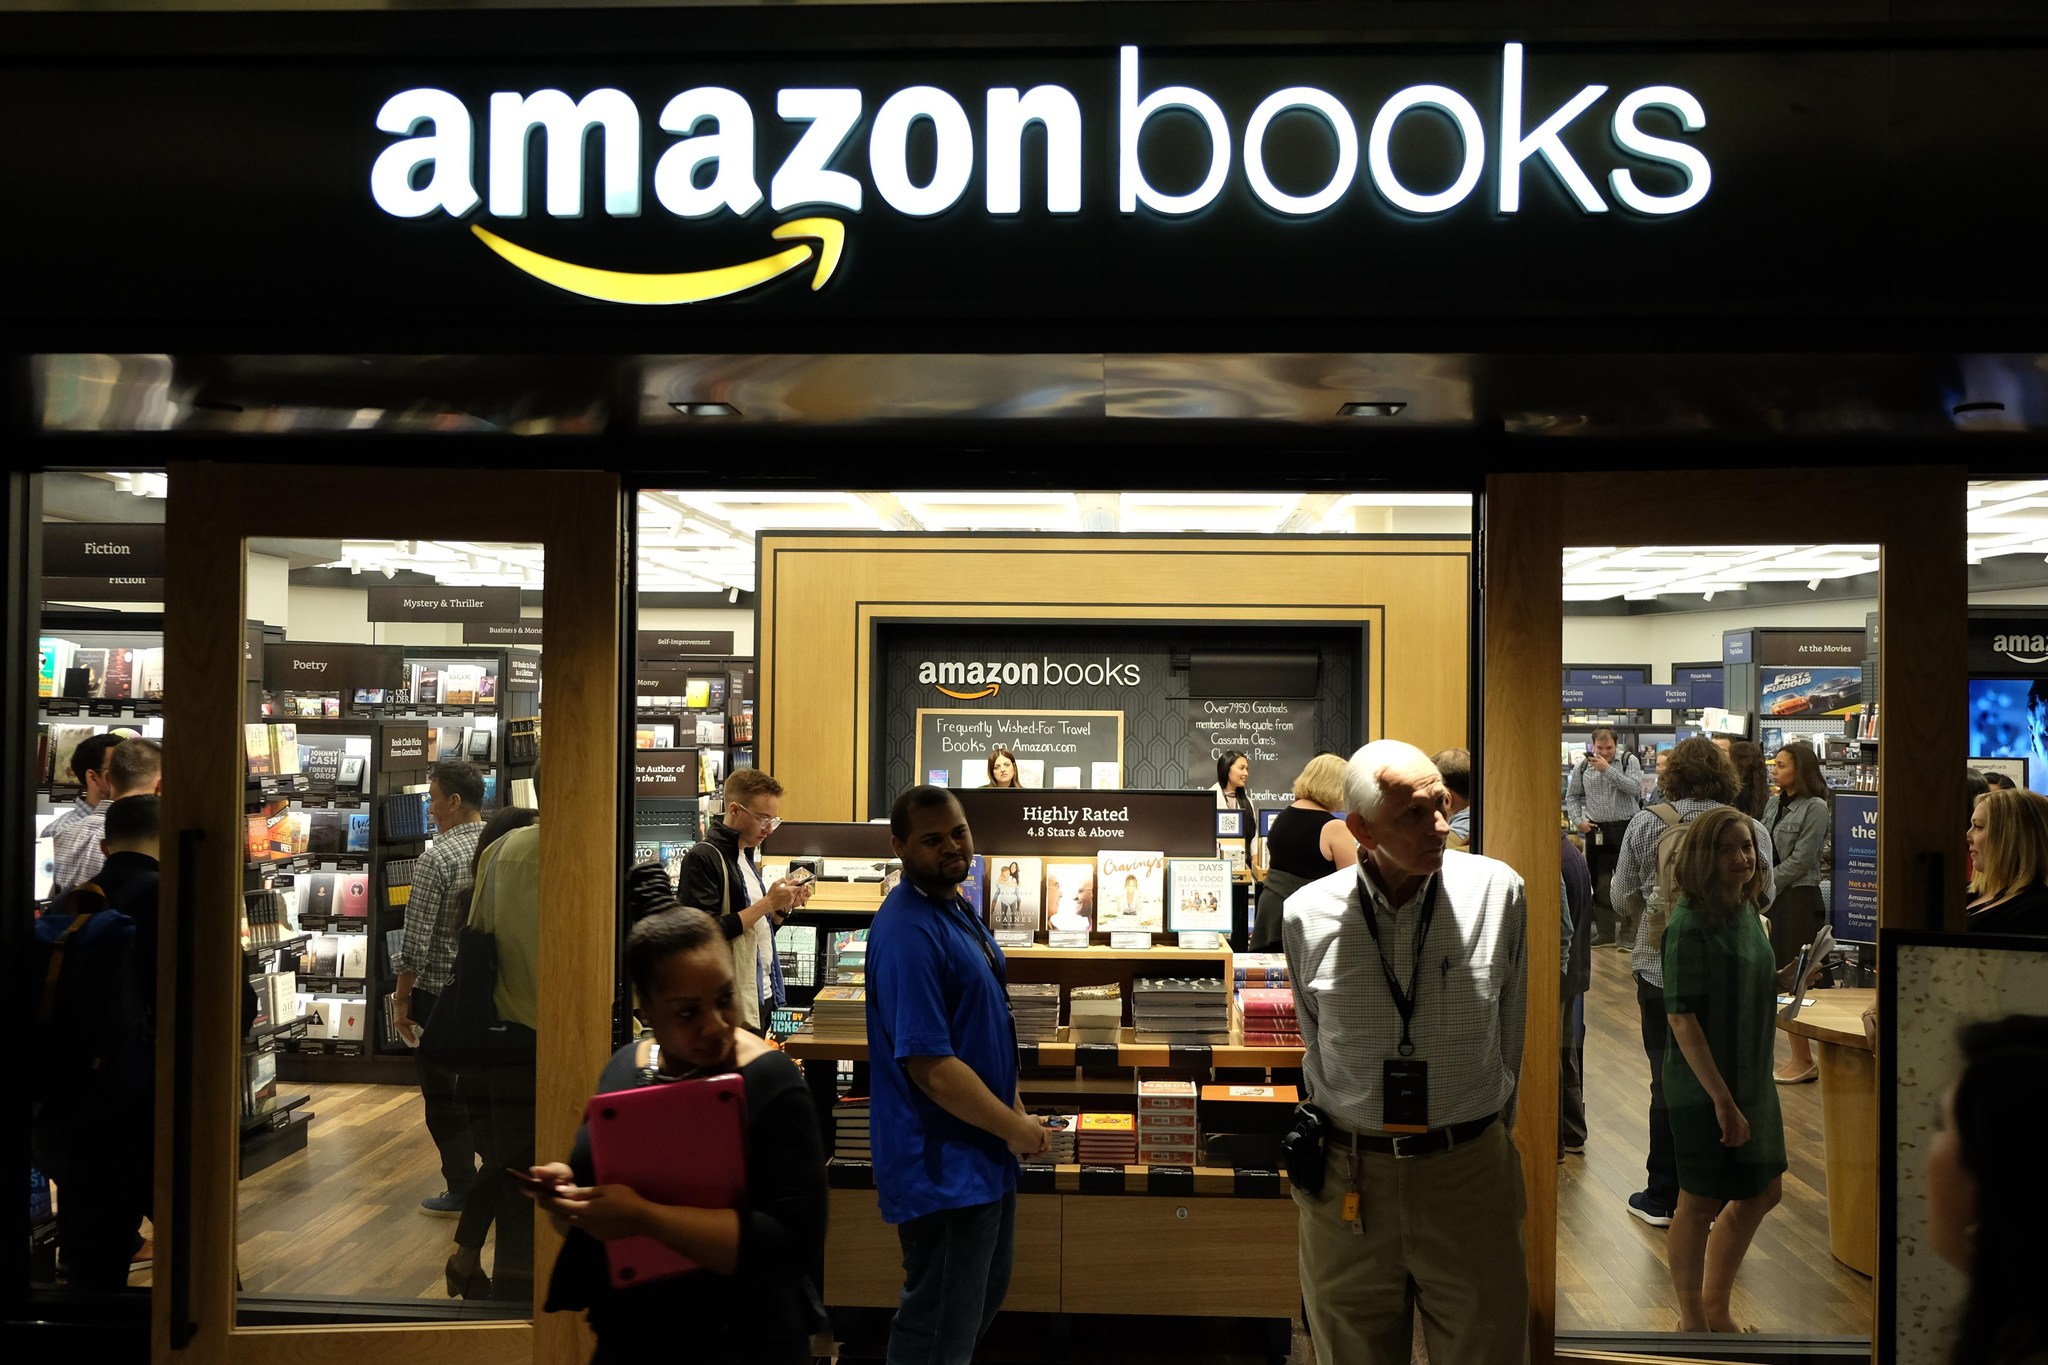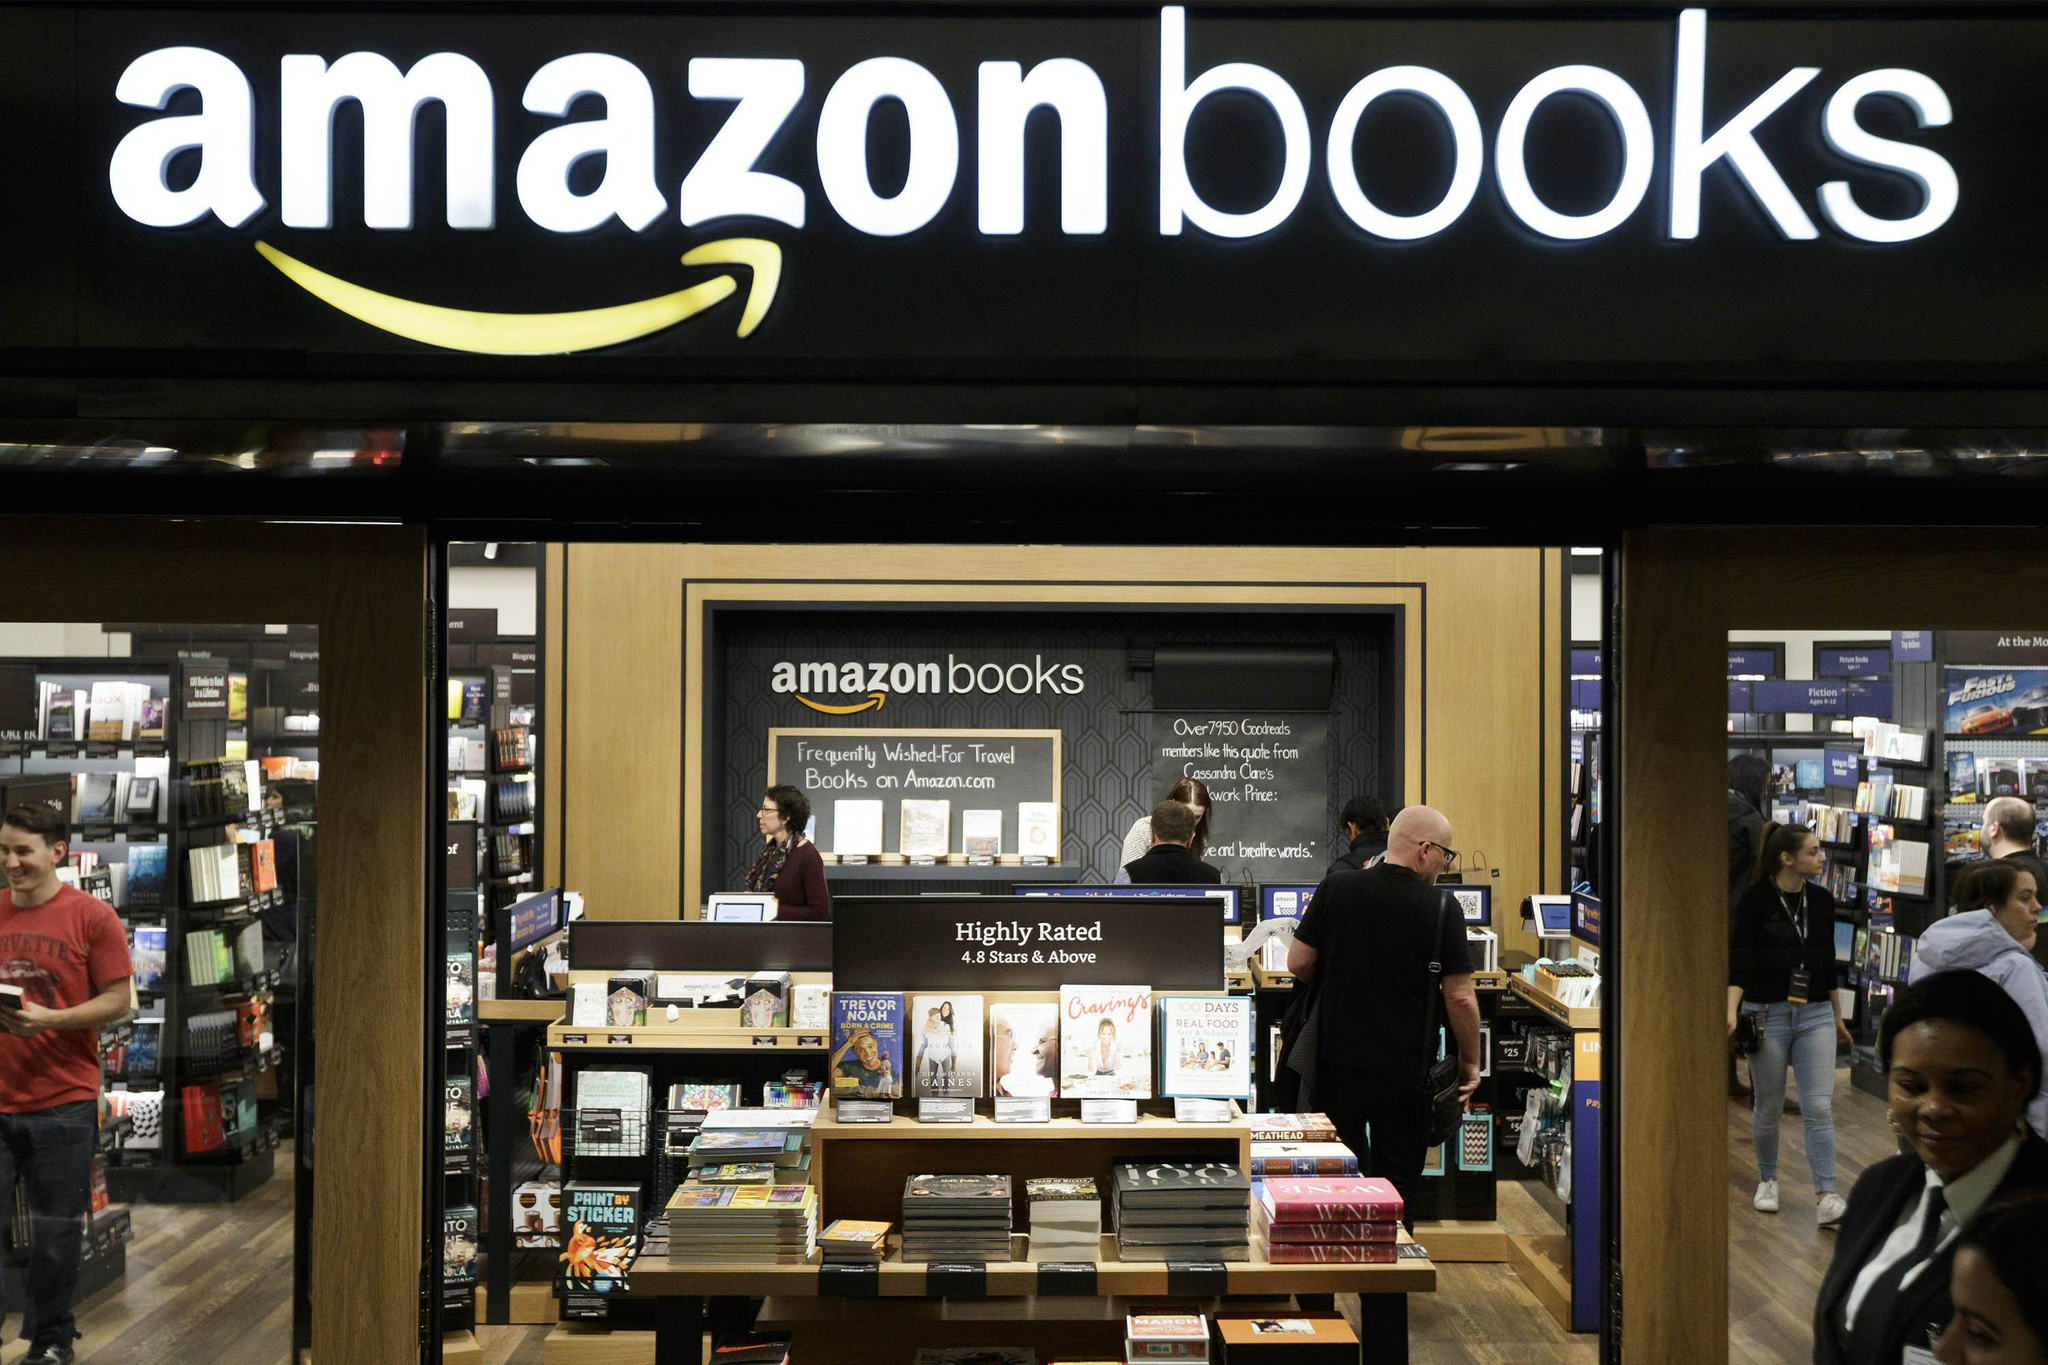The first image is the image on the left, the second image is the image on the right. Analyze the images presented: Is the assertion "One image has an orange poster on the bookshelf that states """"What's the price?"""" and the other image shows a poster that mentions Amazon." valid? Answer yes or no. No. 